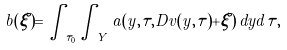<formula> <loc_0><loc_0><loc_500><loc_500>b ( \xi ) = \int _ { \tau _ { 0 } } \int _ { Y } a ( y , \tau , D v ( y , \tau ) + \xi ) \, d y d { \tau } ,</formula> 